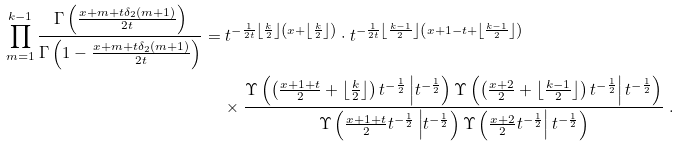Convert formula to latex. <formula><loc_0><loc_0><loc_500><loc_500>\prod _ { m = 1 } ^ { k - 1 } \frac { \Gamma \left ( \frac { x + m + t \delta _ { 2 } ( m + 1 ) } { 2 t } \right ) } { \Gamma \left ( 1 - \frac { x + m + t \delta _ { 2 } ( m + 1 ) } { 2 t } \right ) } & = t ^ { - \frac { 1 } { 2 t } \left \lfloor \frac { k } { 2 } \right \rfloor \left ( x + \left \lfloor \frac { k } { 2 } \right \rfloor \right ) } \cdot t ^ { - \frac { 1 } { 2 t } \left \lfloor \frac { k - 1 } { 2 } \right \rfloor \left ( x + 1 - t + \left \lfloor \frac { k - 1 } { 2 } \right \rfloor \right ) } \\ & \quad \ \times \frac { \Upsilon \left ( \left ( \frac { x + 1 + t } { 2 } + \left \lfloor \frac { k } { 2 } \right \rfloor \right ) t ^ { - \frac { 1 } { 2 } } \left | t ^ { - \frac { 1 } { 2 } } \right ) \Upsilon \left ( \left ( \frac { x + 2 } { 2 } + \left \lfloor \frac { k - 1 } { 2 } \right \rfloor \right ) t ^ { - \frac { 1 } { 2 } } \right | t ^ { - \frac { 1 } { 2 } } \right ) } { \Upsilon \left ( \frac { x + 1 + t } { 2 } t ^ { - \frac { 1 } { 2 } } \left | t ^ { - \frac { 1 } { 2 } } \right ) \Upsilon \left ( \frac { x + 2 } { 2 } t ^ { - \frac { 1 } { 2 } } \right | t ^ { - \frac { 1 } { 2 } } \right ) } \ .</formula> 